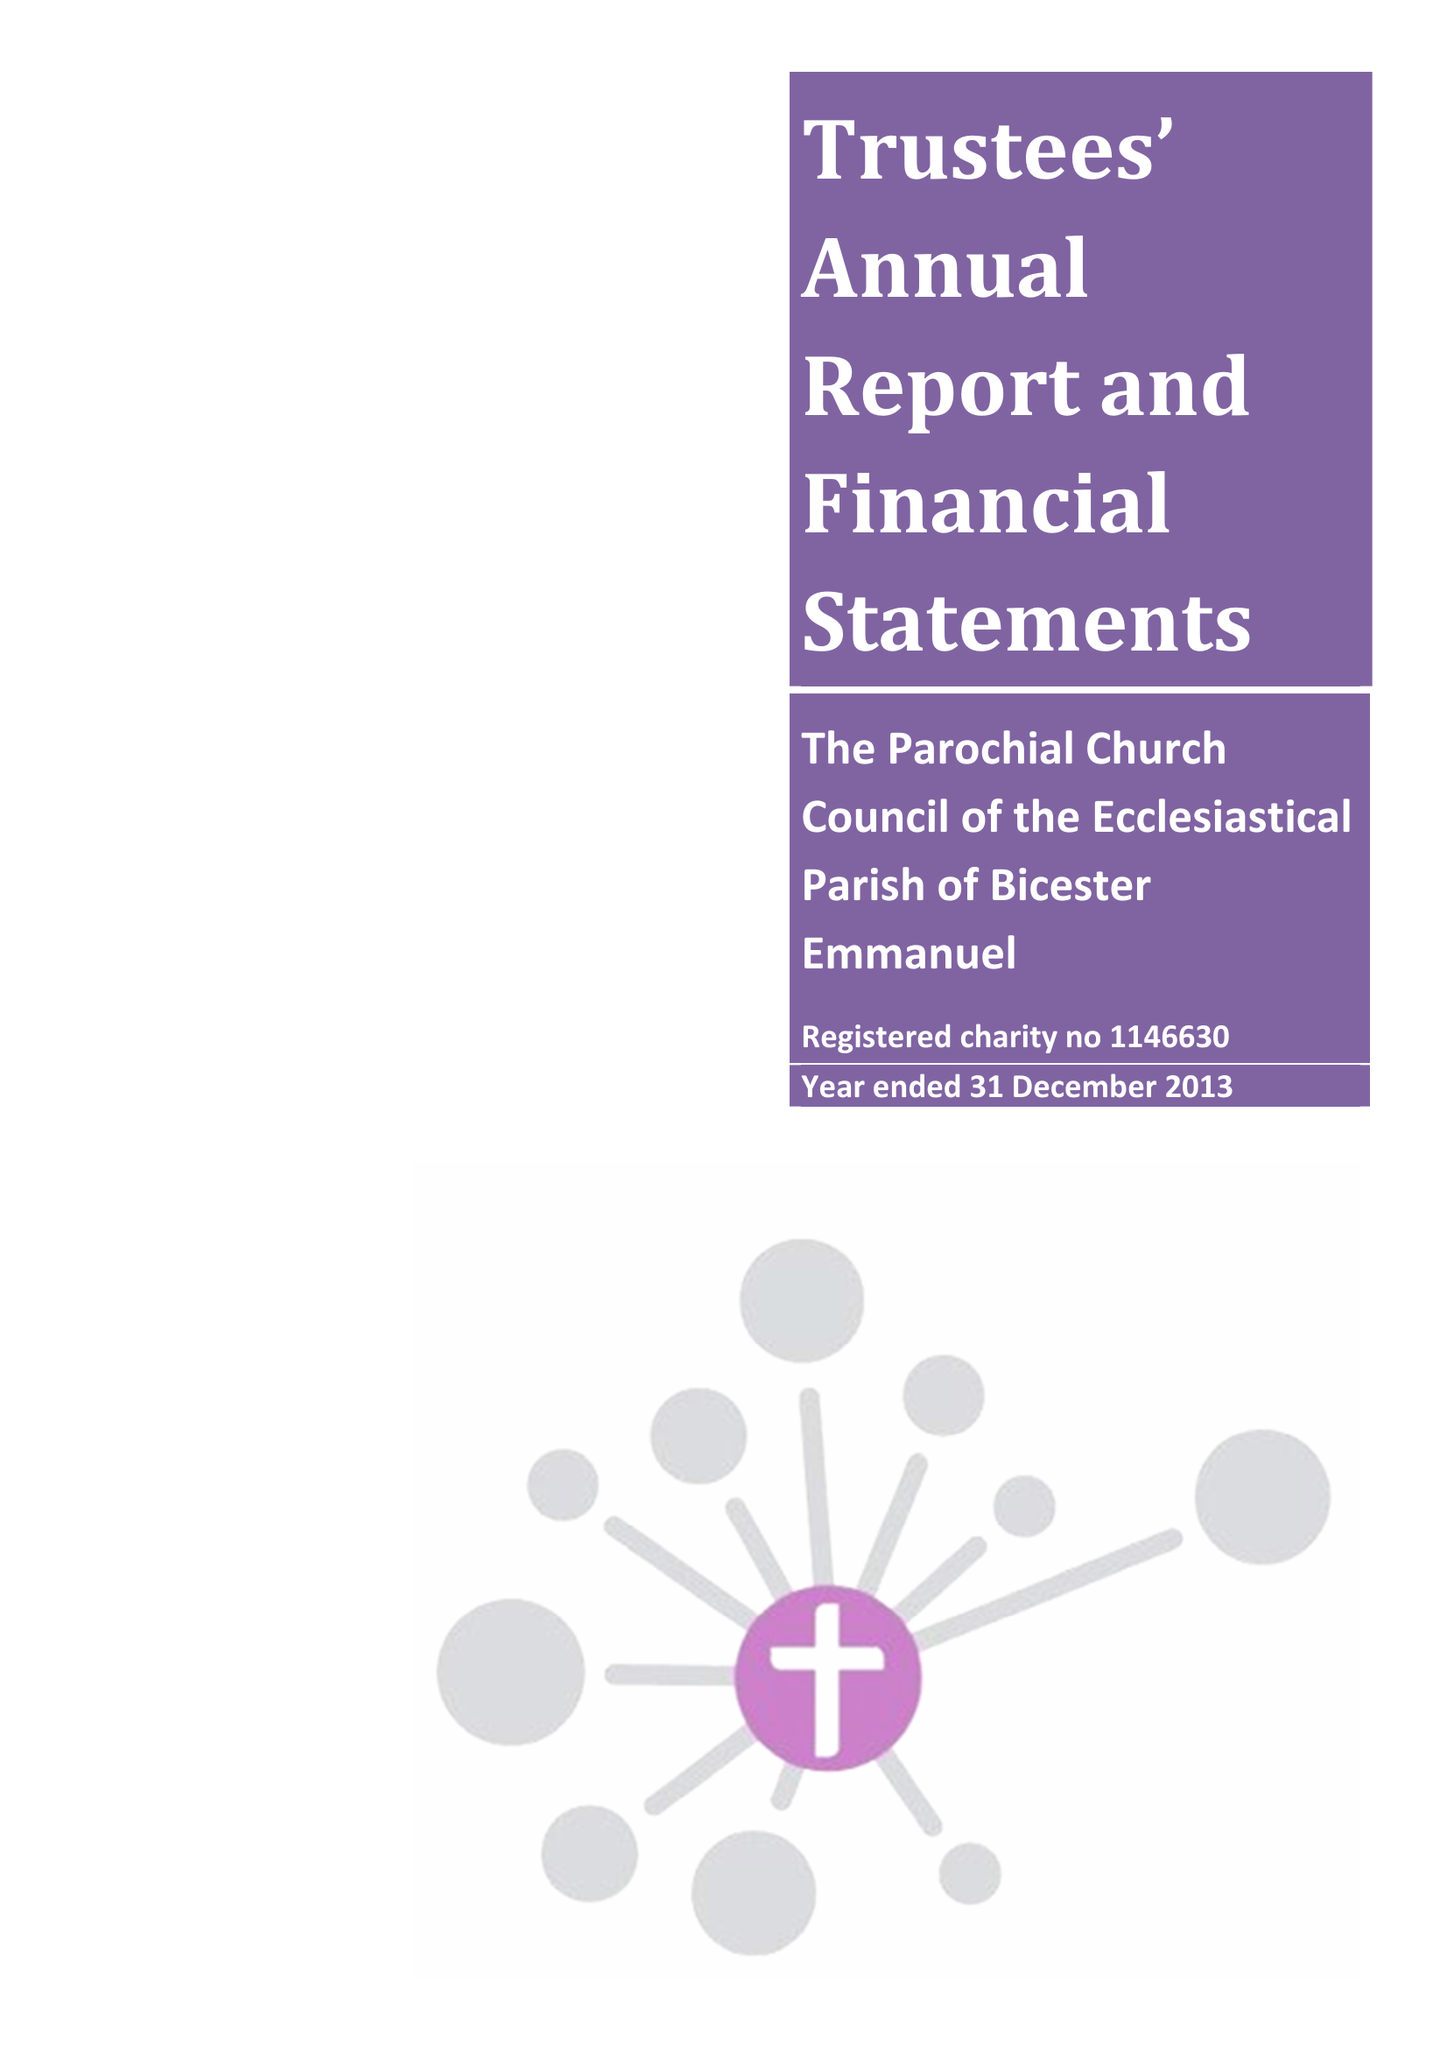What is the value for the address__street_line?
Answer the question using a single word or phrase. 2 BARBERRY PLACE 